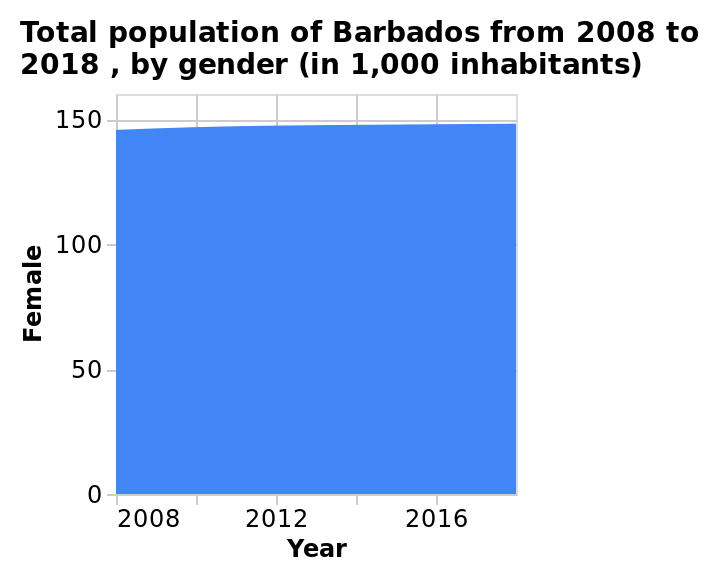<image>
Is the graph indicating an increase or decrease over time? The graph is indicating an increase over time as it has an overall upwards trend. Does the graph show a positive or negative trend?  The graph shows a positive trend as it is overall upwards. What does the y-axis measure in the chart?  The y-axis measures the Female population as a linear scale with a range of 0 to 150. Is the graph indicating a decrease over time as it has an overall downwards trend? No.The graph is indicating an increase over time as it has an overall upwards trend. 